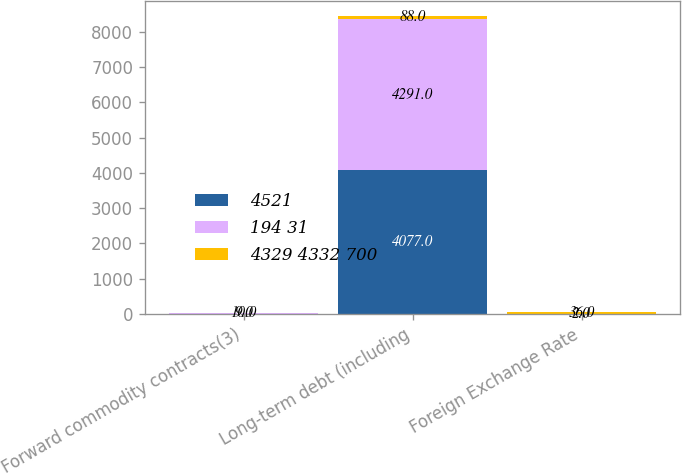Convert chart to OTSL. <chart><loc_0><loc_0><loc_500><loc_500><stacked_bar_chart><ecel><fcel>Forward commodity contracts(3)<fcel>Long-term debt (including<fcel>Foreign Exchange Rate<nl><fcel>4521<fcel>9<fcel>4077<fcel>2<nl><fcel>194 31<fcel>9<fcel>4291<fcel>2<nl><fcel>4329 4332 700<fcel>10<fcel>88<fcel>36<nl></chart> 